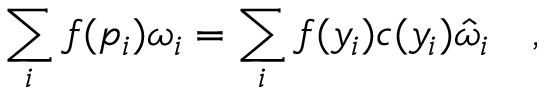Convert formula to latex. <formula><loc_0><loc_0><loc_500><loc_500>\sum _ { i } f ( p _ { i } ) \omega _ { i } = \sum _ { i } f ( y _ { i } ) c ( y _ { i } ) \hat { \omega } _ { i } ,</formula> 